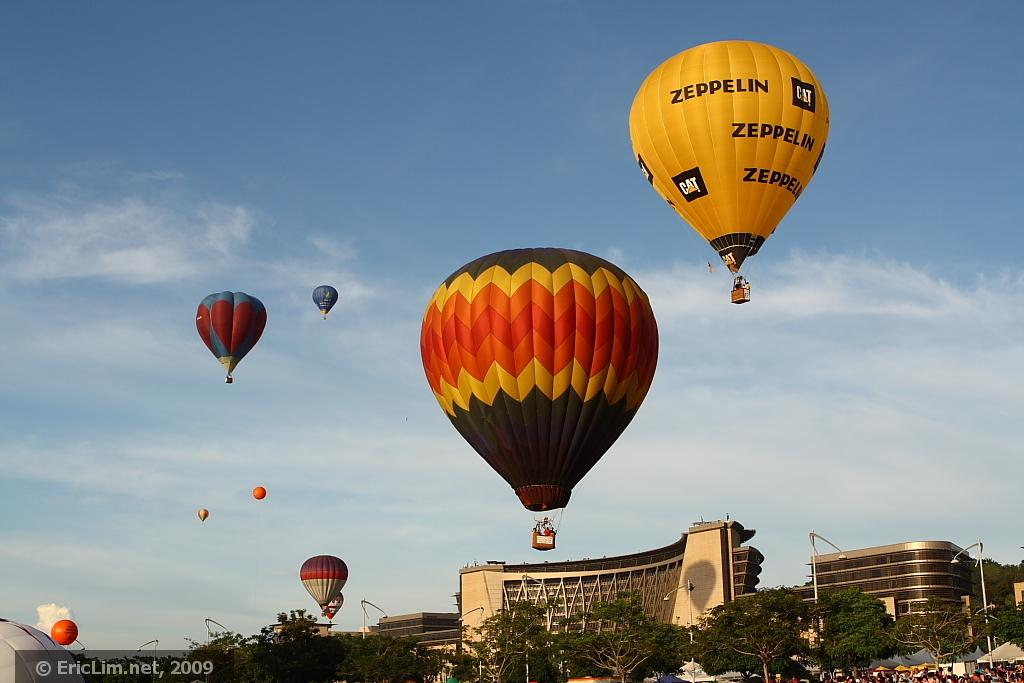<image>
Render a clear and concise summary of the photo. A Zeppelin hot air balloon competes in a show with dozens of other balloons. 